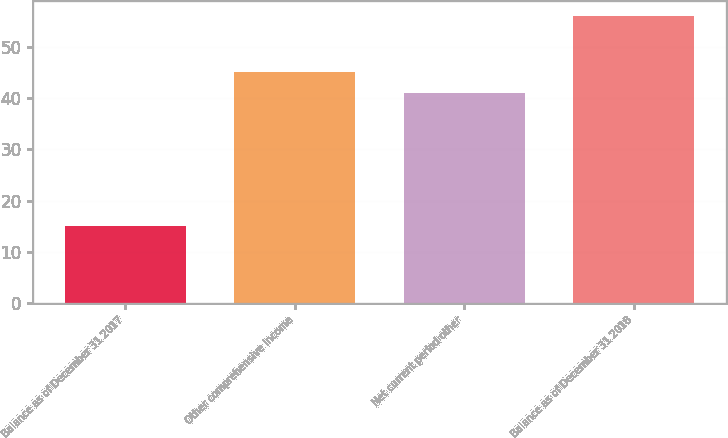Convert chart to OTSL. <chart><loc_0><loc_0><loc_500><loc_500><bar_chart><fcel>Balance as of December 31 2017<fcel>Other comprehensive income<fcel>Net current period other<fcel>Balance as of December 31 2018<nl><fcel>15<fcel>45.1<fcel>41<fcel>56<nl></chart> 